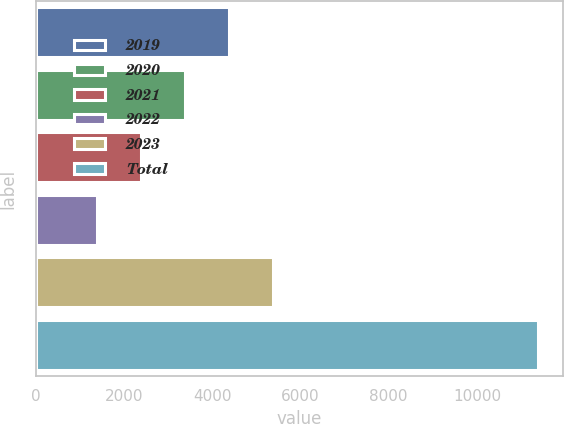Convert chart to OTSL. <chart><loc_0><loc_0><loc_500><loc_500><bar_chart><fcel>2019<fcel>2020<fcel>2021<fcel>2022<fcel>2023<fcel>Total<nl><fcel>4389.3<fcel>3390.2<fcel>2391.1<fcel>1392<fcel>5388.4<fcel>11383<nl></chart> 